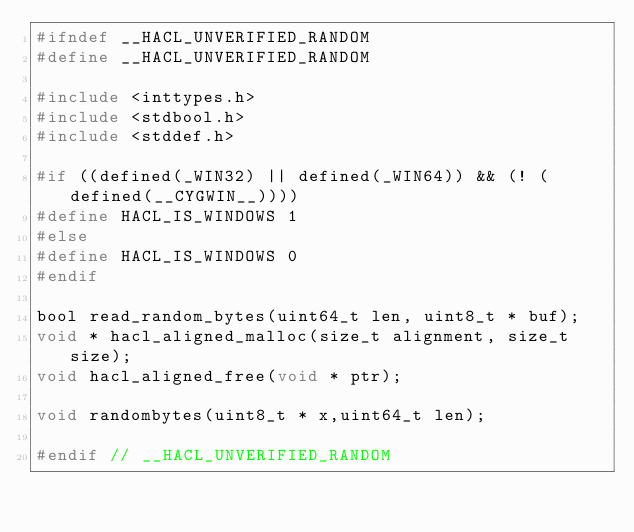Convert code to text. <code><loc_0><loc_0><loc_500><loc_500><_C_>#ifndef __HACL_UNVERIFIED_RANDOM
#define __HACL_UNVERIFIED_RANDOM

#include <inttypes.h>
#include <stdbool.h>
#include <stddef.h>

#if ((defined(_WIN32) || defined(_WIN64)) && (! (defined(__CYGWIN__))))
#define HACL_IS_WINDOWS 1
#else
#define HACL_IS_WINDOWS 0
#endif

bool read_random_bytes(uint64_t len, uint8_t * buf);
void * hacl_aligned_malloc(size_t alignment, size_t size);
void hacl_aligned_free(void * ptr);

void randombytes(uint8_t * x,uint64_t len);

#endif // __HACL_UNVERIFIED_RANDOM

</code> 